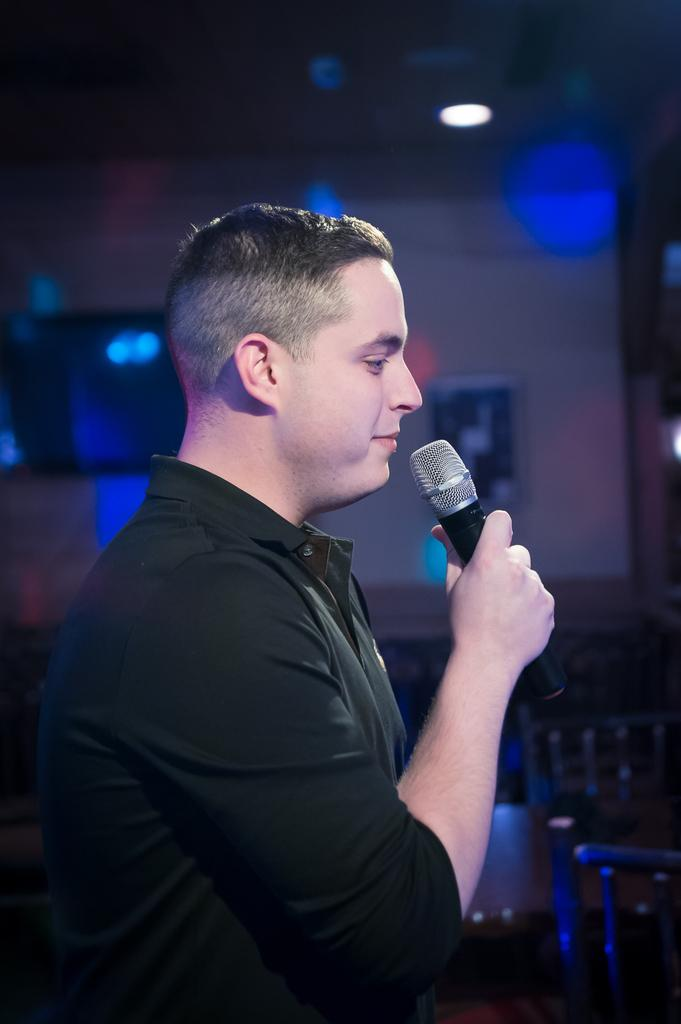What is the main subject of the image? There is a man in the image. What is the man doing in the image? The man is standing and holding a microphone in his hand. What can be seen in the background of the image? There are lights and the ceiling visible in the background of the image. How is the background of the image depicted? The background of the image is blurred. Can you see any deer or squirrels in the image? No, there are no deer or squirrels present in the image. Is this man's home depicted in the image? The provided facts do not indicate whether the man is in his home or not. 